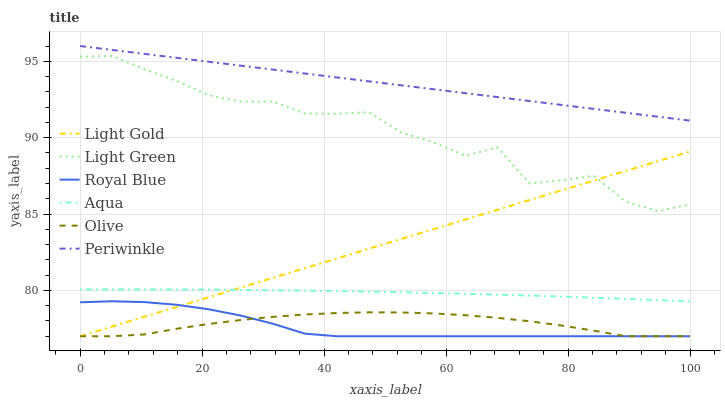Does Royal Blue have the minimum area under the curve?
Answer yes or no. Yes. Does Periwinkle have the maximum area under the curve?
Answer yes or no. Yes. Does Periwinkle have the minimum area under the curve?
Answer yes or no. No. Does Royal Blue have the maximum area under the curve?
Answer yes or no. No. Is Periwinkle the smoothest?
Answer yes or no. Yes. Is Light Green the roughest?
Answer yes or no. Yes. Is Royal Blue the smoothest?
Answer yes or no. No. Is Royal Blue the roughest?
Answer yes or no. No. Does Royal Blue have the lowest value?
Answer yes or no. Yes. Does Periwinkle have the lowest value?
Answer yes or no. No. Does Periwinkle have the highest value?
Answer yes or no. Yes. Does Royal Blue have the highest value?
Answer yes or no. No. Is Light Gold less than Periwinkle?
Answer yes or no. Yes. Is Light Green greater than Aqua?
Answer yes or no. Yes. Does Light Gold intersect Aqua?
Answer yes or no. Yes. Is Light Gold less than Aqua?
Answer yes or no. No. Is Light Gold greater than Aqua?
Answer yes or no. No. Does Light Gold intersect Periwinkle?
Answer yes or no. No. 